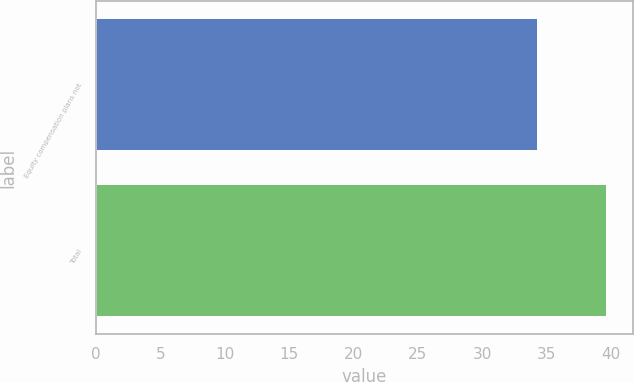<chart> <loc_0><loc_0><loc_500><loc_500><bar_chart><fcel>Equity compensation plans not<fcel>Total<nl><fcel>34.35<fcel>39.69<nl></chart> 